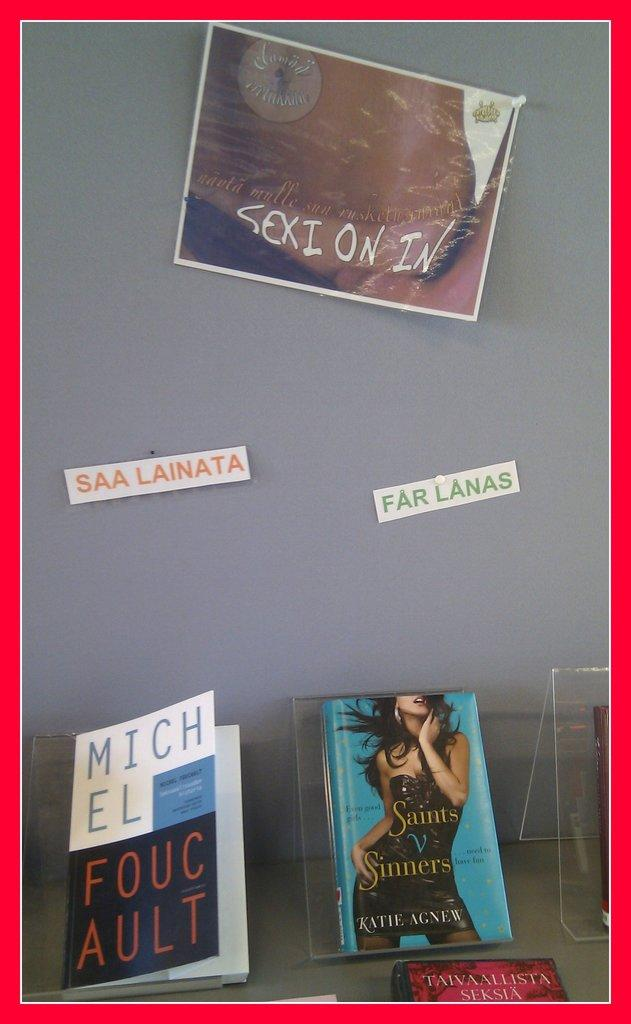<image>
Write a terse but informative summary of the picture. Some books on display including Saints V Sinners by Katie Agnew. 